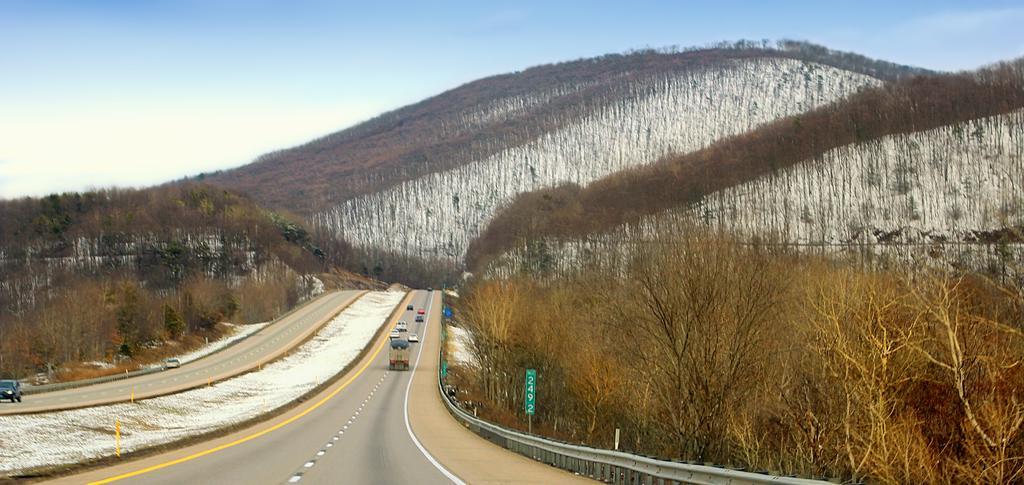How would you summarize this image in a sentence or two? This is an outside view. On the left side, I can see two roads and some vehicles. On both sides of the road I can see the trees. In the background there is a hill. On the top of the image I can see the sky. 